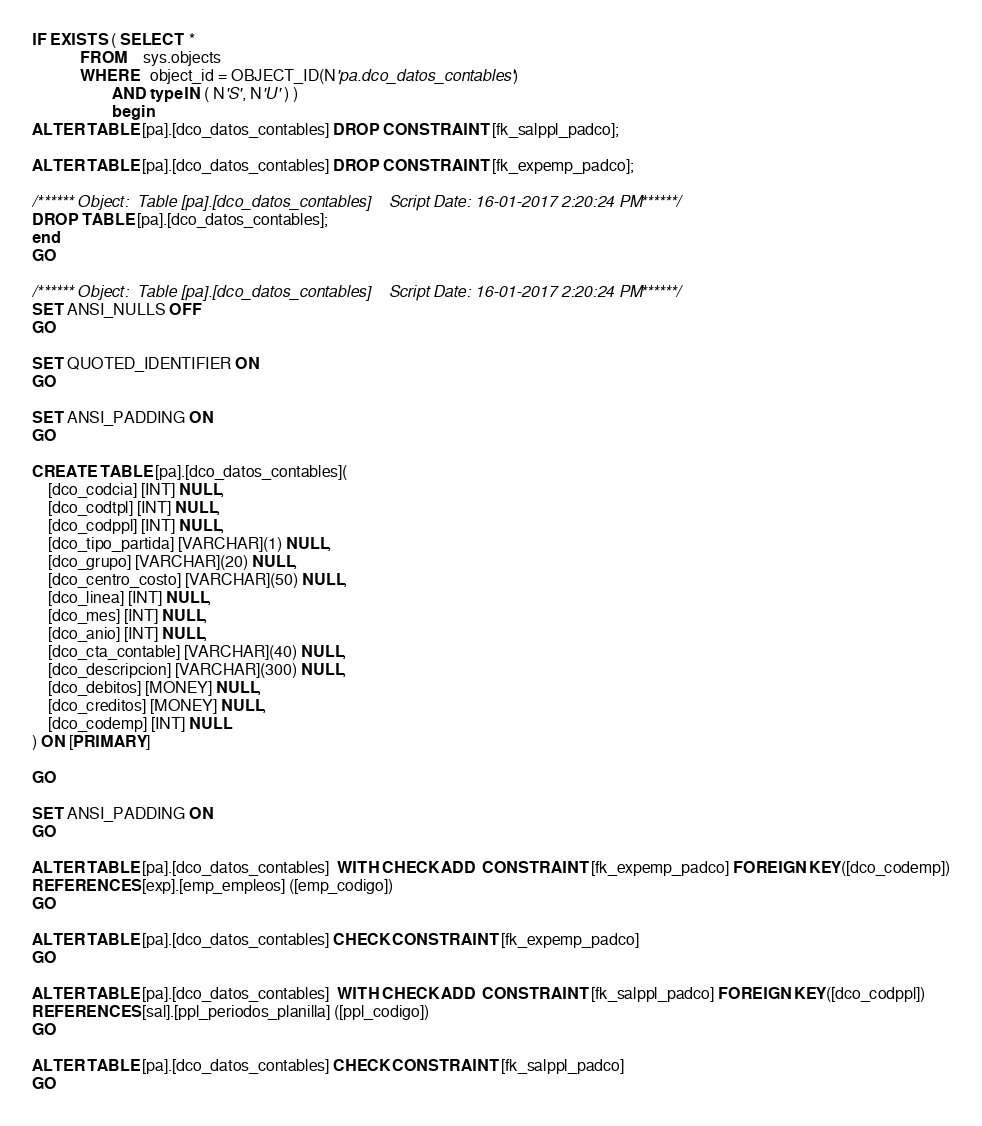<code> <loc_0><loc_0><loc_500><loc_500><_SQL_>
IF EXISTS ( SELECT  *
            FROM    sys.objects
            WHERE   object_id = OBJECT_ID(N'pa.dco_datos_contables')
                    AND type IN ( N'S', N'U' ) )
					begin
ALTER TABLE [pa].[dco_datos_contables] DROP CONSTRAINT [fk_salppl_padco];

ALTER TABLE [pa].[dco_datos_contables] DROP CONSTRAINT [fk_expemp_padco];

/****** Object:  Table [pa].[dco_datos_contables]    Script Date: 16-01-2017 2:20:24 PM ******/
DROP TABLE [pa].[dco_datos_contables];
end
GO

/****** Object:  Table [pa].[dco_datos_contables]    Script Date: 16-01-2017 2:20:24 PM ******/
SET ANSI_NULLS OFF
GO

SET QUOTED_IDENTIFIER ON
GO

SET ANSI_PADDING ON
GO

CREATE TABLE [pa].[dco_datos_contables](
	[dco_codcia] [INT] NULL,
	[dco_codtpl] [INT] NULL,
	[dco_codppl] [INT] NULL,
	[dco_tipo_partida] [VARCHAR](1) NULL,
	[dco_grupo] [VARCHAR](20) NULL,
	[dco_centro_costo] [VARCHAR](50) NULL,
	[dco_linea] [INT] NULL,
	[dco_mes] [INT] NULL,
	[dco_anio] [INT] NULL,
	[dco_cta_contable] [VARCHAR](40) NULL,
	[dco_descripcion] [VARCHAR](300) NULL,
	[dco_debitos] [MONEY] NULL,
	[dco_creditos] [MONEY] NULL,
	[dco_codemp] [INT] NULL
) ON [PRIMARY]

GO

SET ANSI_PADDING ON
GO

ALTER TABLE [pa].[dco_datos_contables]  WITH CHECK ADD  CONSTRAINT [fk_expemp_padco] FOREIGN KEY([dco_codemp])
REFERENCES [exp].[emp_empleos] ([emp_codigo])
GO

ALTER TABLE [pa].[dco_datos_contables] CHECK CONSTRAINT [fk_expemp_padco]
GO

ALTER TABLE [pa].[dco_datos_contables]  WITH CHECK ADD  CONSTRAINT [fk_salppl_padco] FOREIGN KEY([dco_codppl])
REFERENCES [sal].[ppl_periodos_planilla] ([ppl_codigo])
GO

ALTER TABLE [pa].[dco_datos_contables] CHECK CONSTRAINT [fk_salppl_padco]
GO


</code> 